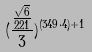Convert formula to latex. <formula><loc_0><loc_0><loc_500><loc_500>( \frac { \frac { \sqrt { 6 } } { 2 2 1 } } { 3 } ) ^ { ( 3 4 9 \cdot 4 ) + 1 }</formula> 